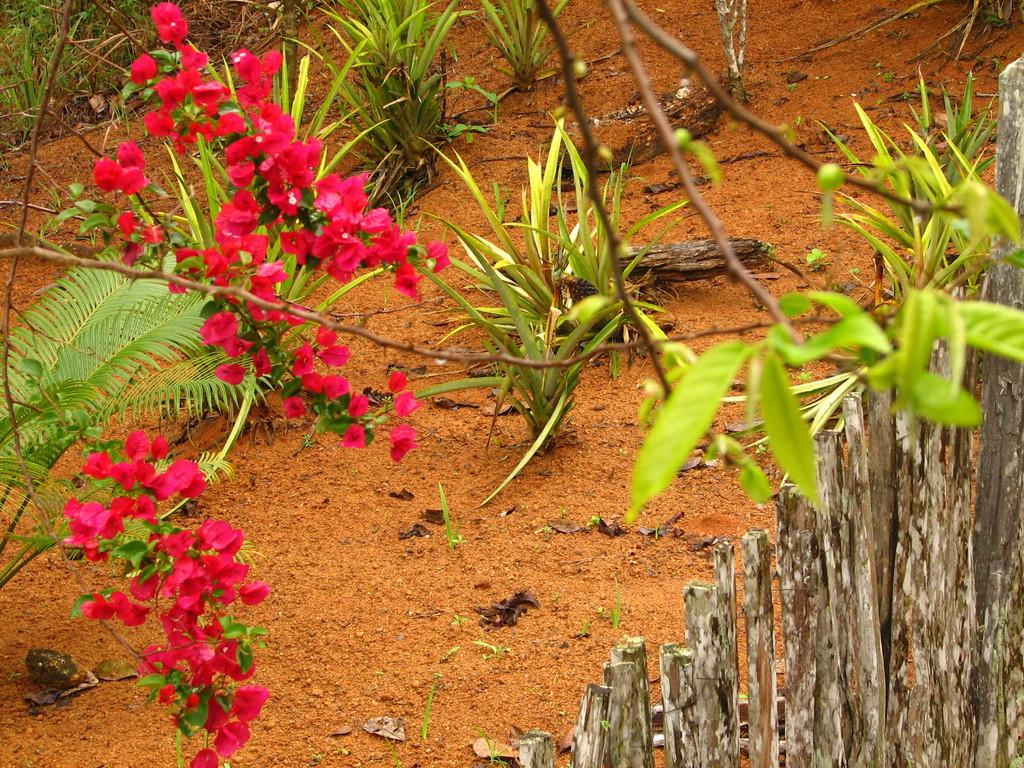What type of living organisms can be seen in the image? Flowers and plants can be seen in the image. Can you describe the fence visible in the image? There is a wooden fence on the right side of the image. What type of connection can be seen between the mother and the stove in the image? There is no mother or stove present in the image. 